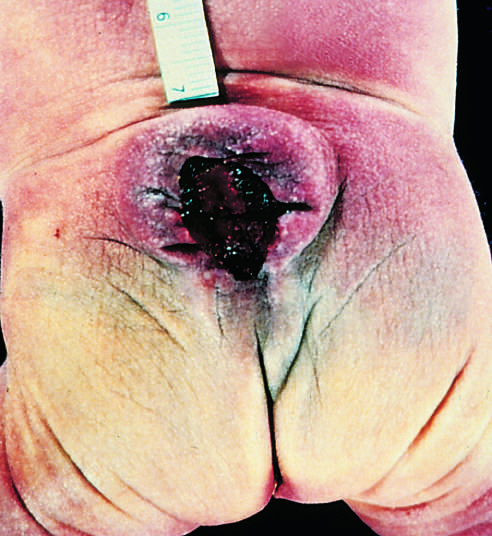what are both meninges and spinal cord parenchyma included in?
Answer the question using a single word or phrase. The cystlike structure visible just above the buttocks 